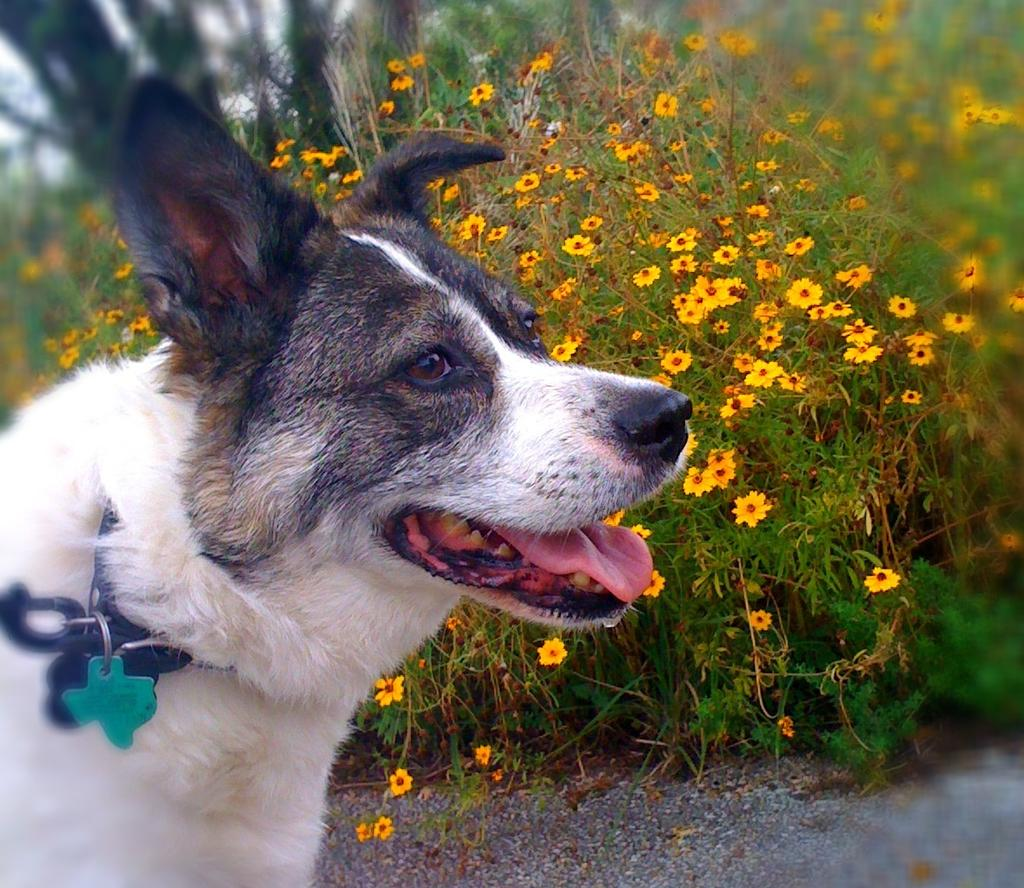What animal is in the image? There is a dog in the image. Where is the dog located in the image? The dog is in the front of the image. What can be seen in the background of the image? There are flowers in the background of the image. Is the dog involved in a fight with another animal in the image? No, there is no indication of a fight or any other animals present in the image. 